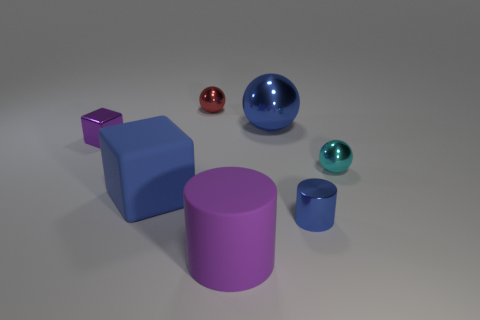Subtract all big metal spheres. How many spheres are left? 2 Subtract 1 balls. How many balls are left? 2 Add 3 spheres. How many objects exist? 10 Subtract all cubes. How many objects are left? 5 Subtract all green balls. Subtract all blue cubes. How many balls are left? 3 Subtract 0 brown blocks. How many objects are left? 7 Subtract all purple rubber things. Subtract all tiny cyan matte cylinders. How many objects are left? 6 Add 1 metallic things. How many metallic things are left? 6 Add 5 small purple metal things. How many small purple metal things exist? 6 